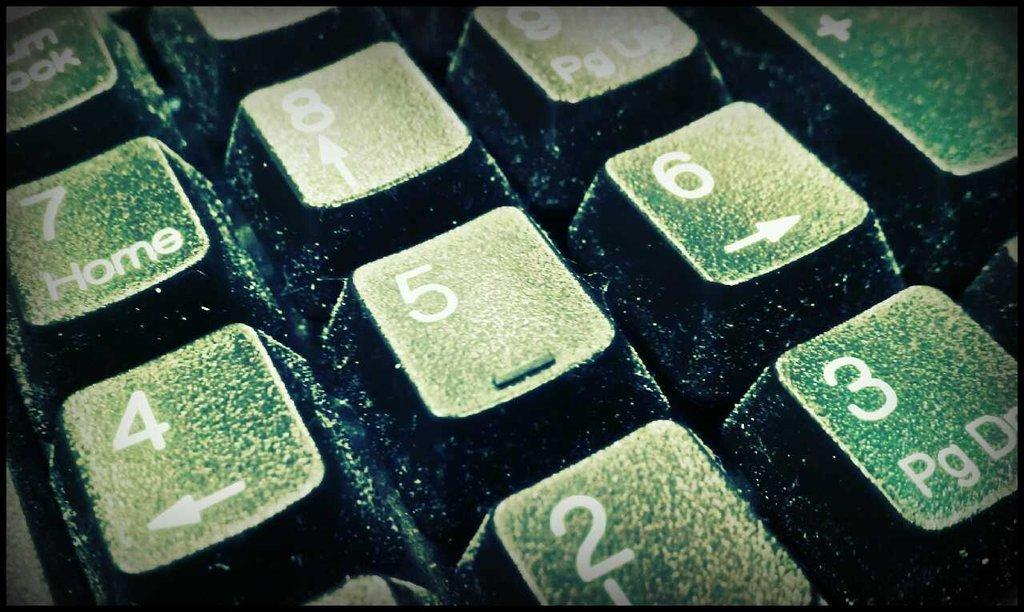<image>
Give a short and clear explanation of the subsequent image. The number 5 key is in the center of a partial image of a keyboard. 